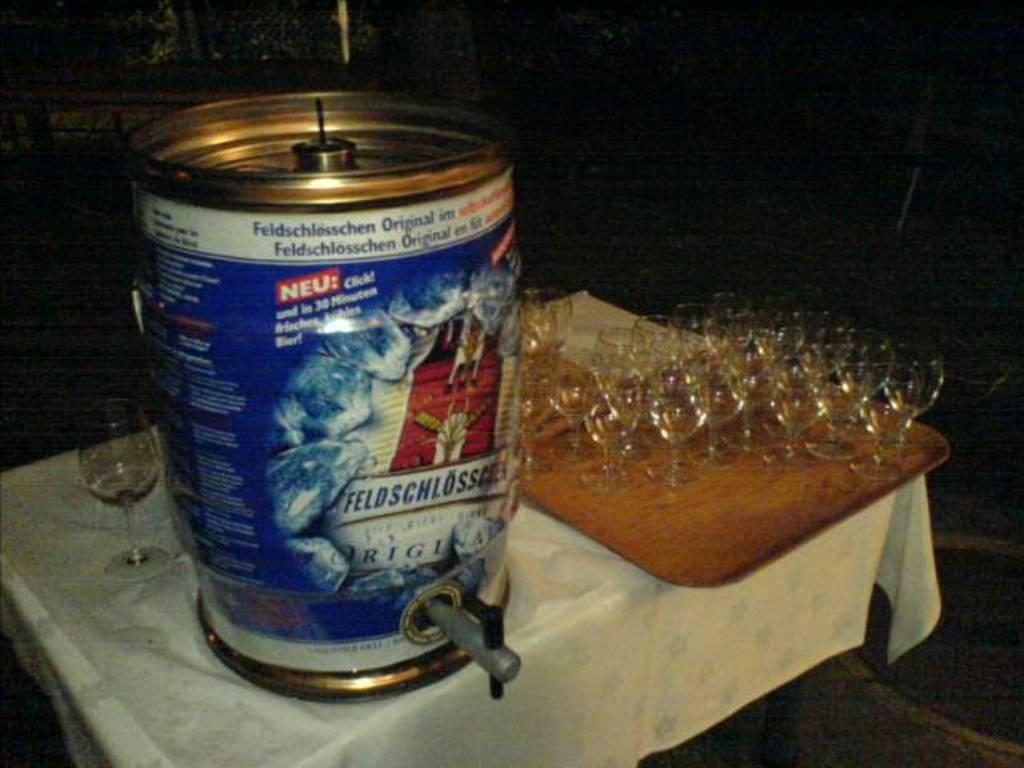<image>
Give a short and clear explanation of the subsequent image. Several wine glasses arearranged on a wooden tray with a Keg with the label for Feldschlosser on it. 